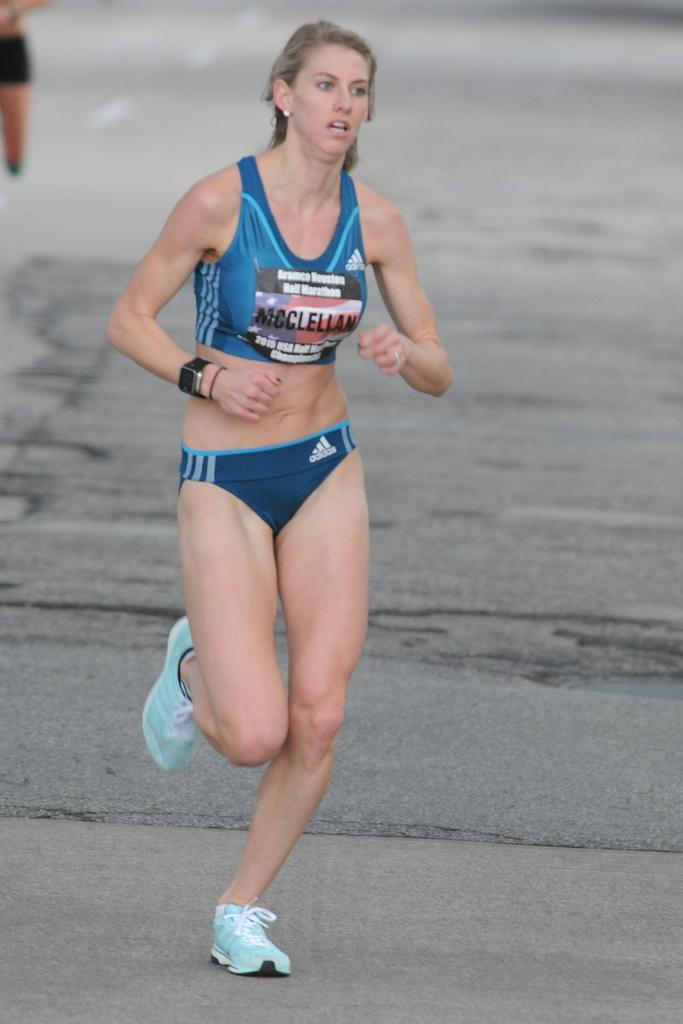Provide a one-sentence caption for the provided image. A woman running who is wearing the tag McClellan. 